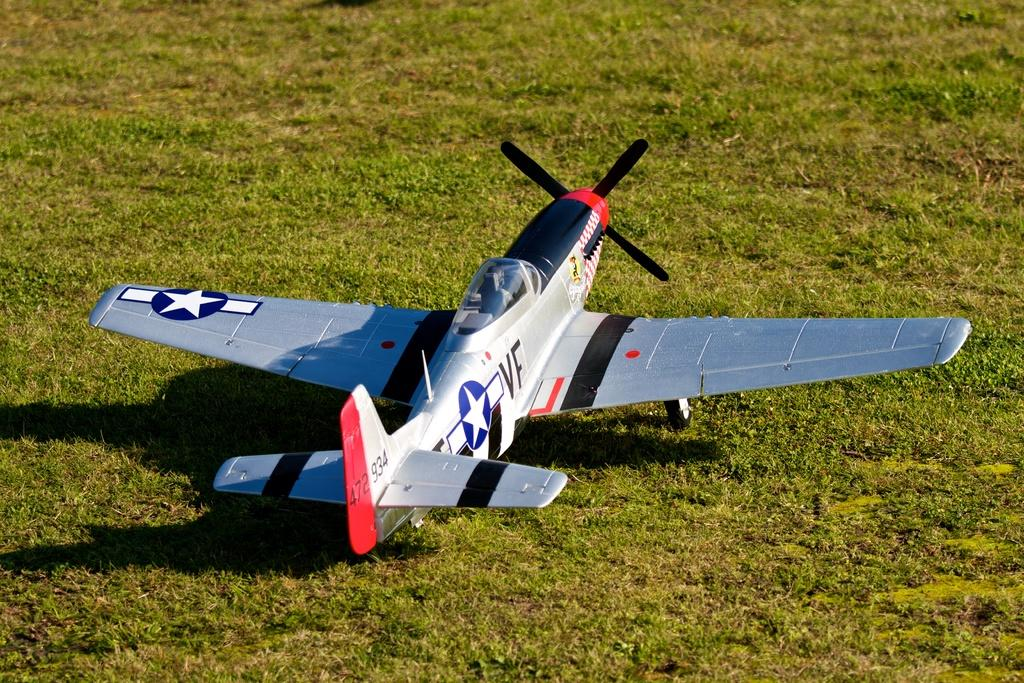What is the main object in the center of the image? There is a toy aeroplane in the center of the image. What type of surface is visible at the bottom of the image? There is grass at the bottom of the image. What type of hat is the toy aeroplane wearing in the image? There is no hat present on the toy aeroplane in the image. What type of cannon is visible in the image? There is no cannon present in the image. 